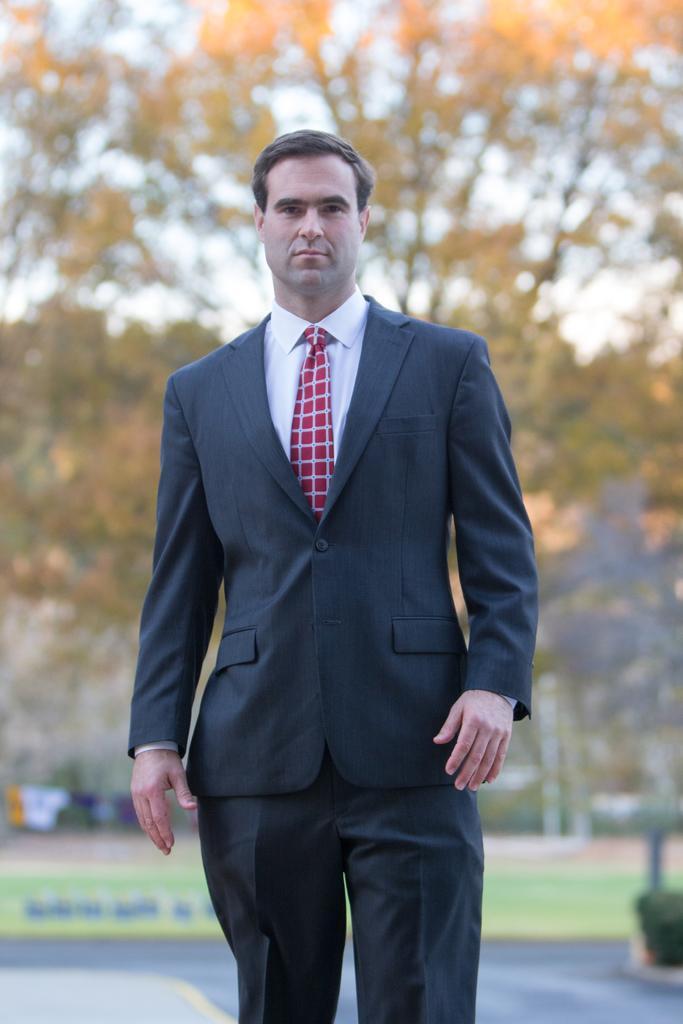In one or two sentences, can you explain what this image depicts? In this image there is a man standing, and in the background there are trees,sky. 